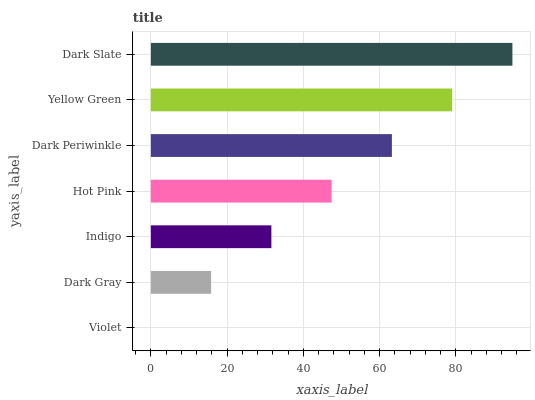Is Violet the minimum?
Answer yes or no. Yes. Is Dark Slate the maximum?
Answer yes or no. Yes. Is Dark Gray the minimum?
Answer yes or no. No. Is Dark Gray the maximum?
Answer yes or no. No. Is Dark Gray greater than Violet?
Answer yes or no. Yes. Is Violet less than Dark Gray?
Answer yes or no. Yes. Is Violet greater than Dark Gray?
Answer yes or no. No. Is Dark Gray less than Violet?
Answer yes or no. No. Is Hot Pink the high median?
Answer yes or no. Yes. Is Hot Pink the low median?
Answer yes or no. Yes. Is Violet the high median?
Answer yes or no. No. Is Dark Gray the low median?
Answer yes or no. No. 